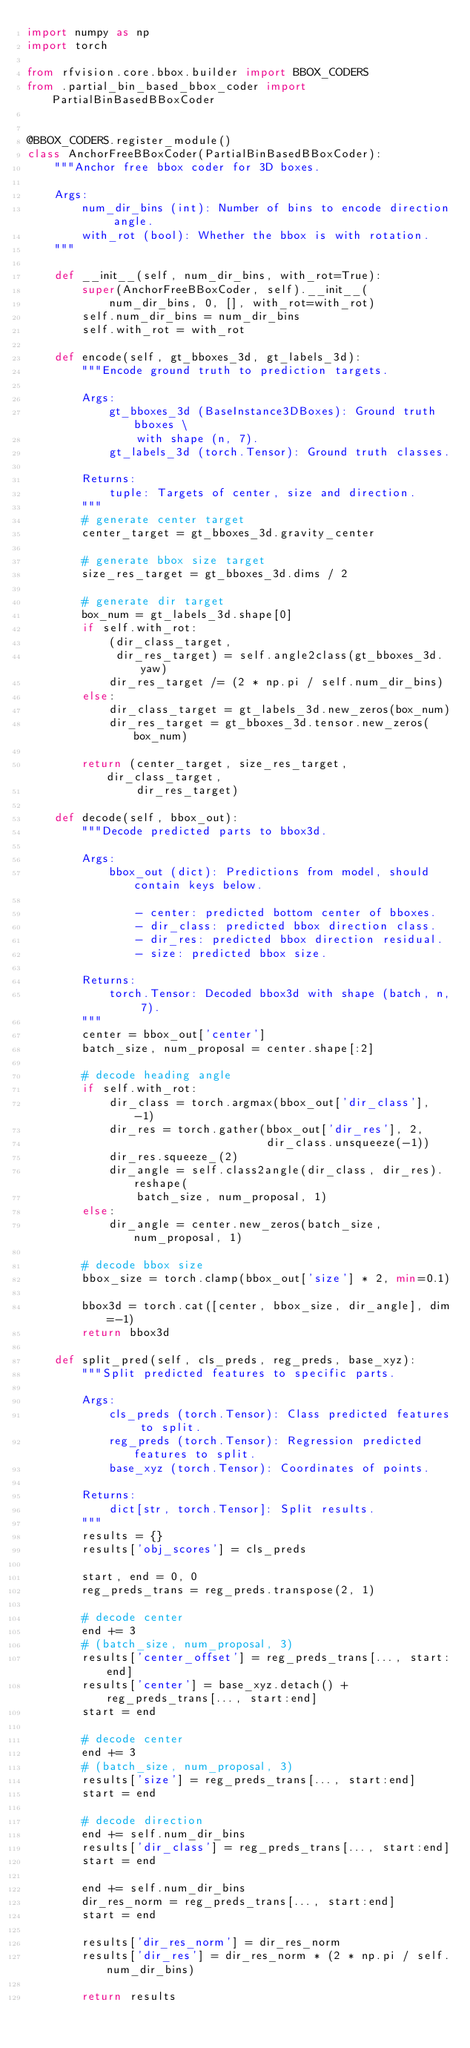Convert code to text. <code><loc_0><loc_0><loc_500><loc_500><_Python_>import numpy as np
import torch

from rfvision.core.bbox.builder import BBOX_CODERS
from .partial_bin_based_bbox_coder import PartialBinBasedBBoxCoder


@BBOX_CODERS.register_module()
class AnchorFreeBBoxCoder(PartialBinBasedBBoxCoder):
    """Anchor free bbox coder for 3D boxes.

    Args:
        num_dir_bins (int): Number of bins to encode direction angle.
        with_rot (bool): Whether the bbox is with rotation.
    """

    def __init__(self, num_dir_bins, with_rot=True):
        super(AnchorFreeBBoxCoder, self).__init__(
            num_dir_bins, 0, [], with_rot=with_rot)
        self.num_dir_bins = num_dir_bins
        self.with_rot = with_rot

    def encode(self, gt_bboxes_3d, gt_labels_3d):
        """Encode ground truth to prediction targets.

        Args:
            gt_bboxes_3d (BaseInstance3DBoxes): Ground truth bboxes \
                with shape (n, 7).
            gt_labels_3d (torch.Tensor): Ground truth classes.

        Returns:
            tuple: Targets of center, size and direction.
        """
        # generate center target
        center_target = gt_bboxes_3d.gravity_center

        # generate bbox size target
        size_res_target = gt_bboxes_3d.dims / 2

        # generate dir target
        box_num = gt_labels_3d.shape[0]
        if self.with_rot:
            (dir_class_target,
             dir_res_target) = self.angle2class(gt_bboxes_3d.yaw)
            dir_res_target /= (2 * np.pi / self.num_dir_bins)
        else:
            dir_class_target = gt_labels_3d.new_zeros(box_num)
            dir_res_target = gt_bboxes_3d.tensor.new_zeros(box_num)

        return (center_target, size_res_target, dir_class_target,
                dir_res_target)

    def decode(self, bbox_out):
        """Decode predicted parts to bbox3d.

        Args:
            bbox_out (dict): Predictions from model, should contain keys below.

                - center: predicted bottom center of bboxes.
                - dir_class: predicted bbox direction class.
                - dir_res: predicted bbox direction residual.
                - size: predicted bbox size.

        Returns:
            torch.Tensor: Decoded bbox3d with shape (batch, n, 7).
        """
        center = bbox_out['center']
        batch_size, num_proposal = center.shape[:2]

        # decode heading angle
        if self.with_rot:
            dir_class = torch.argmax(bbox_out['dir_class'], -1)
            dir_res = torch.gather(bbox_out['dir_res'], 2,
                                   dir_class.unsqueeze(-1))
            dir_res.squeeze_(2)
            dir_angle = self.class2angle(dir_class, dir_res).reshape(
                batch_size, num_proposal, 1)
        else:
            dir_angle = center.new_zeros(batch_size, num_proposal, 1)

        # decode bbox size
        bbox_size = torch.clamp(bbox_out['size'] * 2, min=0.1)

        bbox3d = torch.cat([center, bbox_size, dir_angle], dim=-1)
        return bbox3d

    def split_pred(self, cls_preds, reg_preds, base_xyz):
        """Split predicted features to specific parts.

        Args:
            cls_preds (torch.Tensor): Class predicted features to split.
            reg_preds (torch.Tensor): Regression predicted features to split.
            base_xyz (torch.Tensor): Coordinates of points.

        Returns:
            dict[str, torch.Tensor]: Split results.
        """
        results = {}
        results['obj_scores'] = cls_preds

        start, end = 0, 0
        reg_preds_trans = reg_preds.transpose(2, 1)

        # decode center
        end += 3
        # (batch_size, num_proposal, 3)
        results['center_offset'] = reg_preds_trans[..., start:end]
        results['center'] = base_xyz.detach() + reg_preds_trans[..., start:end]
        start = end

        # decode center
        end += 3
        # (batch_size, num_proposal, 3)
        results['size'] = reg_preds_trans[..., start:end]
        start = end

        # decode direction
        end += self.num_dir_bins
        results['dir_class'] = reg_preds_trans[..., start:end]
        start = end

        end += self.num_dir_bins
        dir_res_norm = reg_preds_trans[..., start:end]
        start = end

        results['dir_res_norm'] = dir_res_norm
        results['dir_res'] = dir_res_norm * (2 * np.pi / self.num_dir_bins)

        return results
</code> 